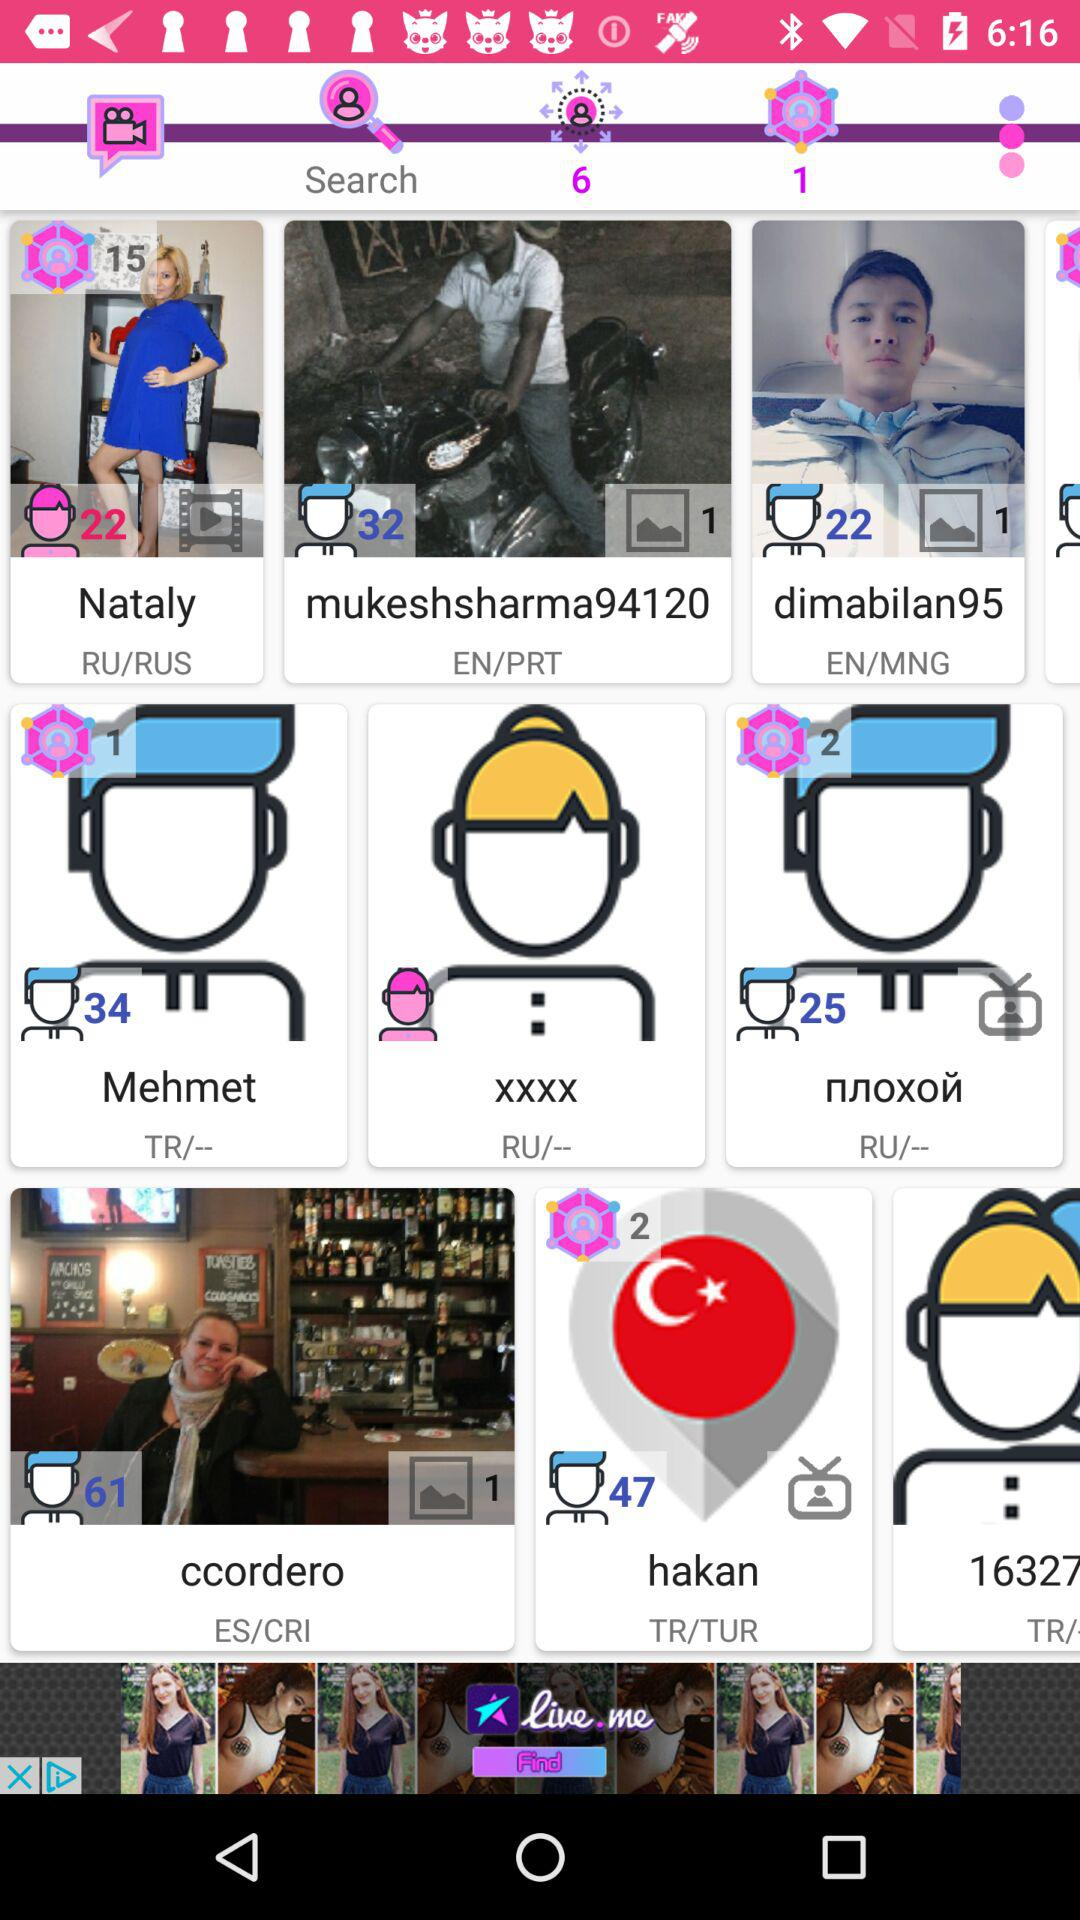What is the age of Nataly? Nataly is 22 years old. 